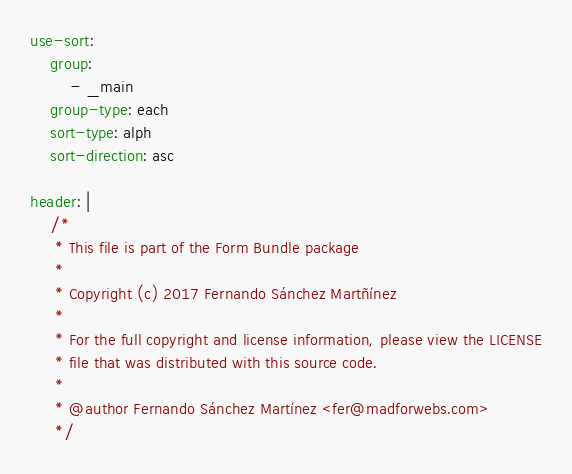<code> <loc_0><loc_0><loc_500><loc_500><_YAML_>use-sort:
    group:
        - _main
    group-type: each
    sort-type: alph
    sort-direction: asc

header: |
    /*
     * This file is part of the Form Bundle package
     *
     * Copyright (c) 2017 Fernando Sánchez Martñínez
     *
     * For the full copyright and license information, please view the LICENSE
     * file that was distributed with this source code.
     *
     * @author Fernando Sánchez Martínez <fer@madforwebs.com>
     */
</code> 